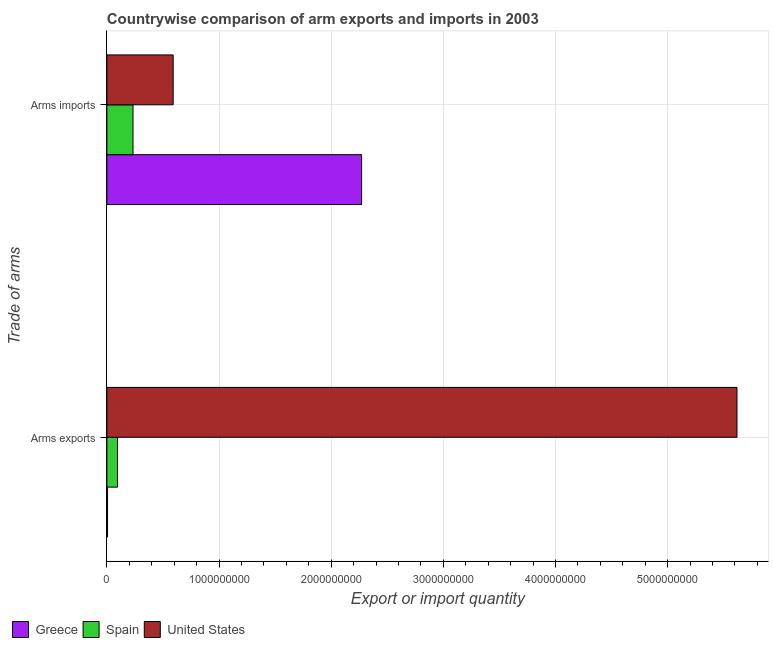Are the number of bars per tick equal to the number of legend labels?
Your answer should be compact. Yes. Are the number of bars on each tick of the Y-axis equal?
Make the answer very short. Yes. What is the label of the 1st group of bars from the top?
Keep it short and to the point. Arms imports. What is the arms exports in Greece?
Your answer should be compact. 6.00e+06. Across all countries, what is the maximum arms imports?
Keep it short and to the point. 2.27e+09. Across all countries, what is the minimum arms imports?
Offer a very short reply. 2.33e+08. In which country was the arms imports maximum?
Make the answer very short. Greece. In which country was the arms exports minimum?
Your answer should be compact. Greece. What is the total arms exports in the graph?
Your answer should be compact. 5.72e+09. What is the difference between the arms exports in Greece and that in United States?
Keep it short and to the point. -5.61e+09. What is the difference between the arms exports in Spain and the arms imports in Greece?
Ensure brevity in your answer.  -2.18e+09. What is the average arms exports per country?
Provide a succinct answer. 1.91e+09. What is the difference between the arms exports and arms imports in Spain?
Make the answer very short. -1.38e+08. What is the ratio of the arms exports in Spain to that in Greece?
Keep it short and to the point. 15.83. What does the 1st bar from the top in Arms imports represents?
Keep it short and to the point. United States. How many bars are there?
Ensure brevity in your answer.  6. How many countries are there in the graph?
Offer a very short reply. 3. Does the graph contain any zero values?
Offer a very short reply. No. How are the legend labels stacked?
Your answer should be very brief. Horizontal. What is the title of the graph?
Give a very brief answer. Countrywise comparison of arm exports and imports in 2003. Does "Seychelles" appear as one of the legend labels in the graph?
Offer a very short reply. No. What is the label or title of the X-axis?
Keep it short and to the point. Export or import quantity. What is the label or title of the Y-axis?
Your response must be concise. Trade of arms. What is the Export or import quantity in Greece in Arms exports?
Your answer should be very brief. 6.00e+06. What is the Export or import quantity of Spain in Arms exports?
Provide a succinct answer. 9.50e+07. What is the Export or import quantity of United States in Arms exports?
Provide a succinct answer. 5.62e+09. What is the Export or import quantity in Greece in Arms imports?
Your response must be concise. 2.27e+09. What is the Export or import quantity of Spain in Arms imports?
Offer a very short reply. 2.33e+08. What is the Export or import quantity of United States in Arms imports?
Give a very brief answer. 5.91e+08. Across all Trade of arms, what is the maximum Export or import quantity in Greece?
Provide a short and direct response. 2.27e+09. Across all Trade of arms, what is the maximum Export or import quantity of Spain?
Make the answer very short. 2.33e+08. Across all Trade of arms, what is the maximum Export or import quantity in United States?
Your response must be concise. 5.62e+09. Across all Trade of arms, what is the minimum Export or import quantity of Greece?
Offer a terse response. 6.00e+06. Across all Trade of arms, what is the minimum Export or import quantity of Spain?
Provide a short and direct response. 9.50e+07. Across all Trade of arms, what is the minimum Export or import quantity of United States?
Keep it short and to the point. 5.91e+08. What is the total Export or import quantity in Greece in the graph?
Make the answer very short. 2.28e+09. What is the total Export or import quantity of Spain in the graph?
Provide a succinct answer. 3.28e+08. What is the total Export or import quantity of United States in the graph?
Your response must be concise. 6.21e+09. What is the difference between the Export or import quantity in Greece in Arms exports and that in Arms imports?
Keep it short and to the point. -2.26e+09. What is the difference between the Export or import quantity of Spain in Arms exports and that in Arms imports?
Your answer should be very brief. -1.38e+08. What is the difference between the Export or import quantity in United States in Arms exports and that in Arms imports?
Your answer should be compact. 5.03e+09. What is the difference between the Export or import quantity in Greece in Arms exports and the Export or import quantity in Spain in Arms imports?
Offer a terse response. -2.27e+08. What is the difference between the Export or import quantity of Greece in Arms exports and the Export or import quantity of United States in Arms imports?
Make the answer very short. -5.85e+08. What is the difference between the Export or import quantity in Spain in Arms exports and the Export or import quantity in United States in Arms imports?
Provide a succinct answer. -4.96e+08. What is the average Export or import quantity in Greece per Trade of arms?
Your response must be concise. 1.14e+09. What is the average Export or import quantity in Spain per Trade of arms?
Your answer should be compact. 1.64e+08. What is the average Export or import quantity of United States per Trade of arms?
Give a very brief answer. 3.10e+09. What is the difference between the Export or import quantity in Greece and Export or import quantity in Spain in Arms exports?
Your answer should be compact. -8.90e+07. What is the difference between the Export or import quantity of Greece and Export or import quantity of United States in Arms exports?
Give a very brief answer. -5.61e+09. What is the difference between the Export or import quantity of Spain and Export or import quantity of United States in Arms exports?
Keep it short and to the point. -5.52e+09. What is the difference between the Export or import quantity in Greece and Export or import quantity in Spain in Arms imports?
Provide a short and direct response. 2.04e+09. What is the difference between the Export or import quantity of Greece and Export or import quantity of United States in Arms imports?
Your response must be concise. 1.68e+09. What is the difference between the Export or import quantity in Spain and Export or import quantity in United States in Arms imports?
Provide a succinct answer. -3.58e+08. What is the ratio of the Export or import quantity in Greece in Arms exports to that in Arms imports?
Your response must be concise. 0. What is the ratio of the Export or import quantity in Spain in Arms exports to that in Arms imports?
Your answer should be very brief. 0.41. What is the ratio of the Export or import quantity in United States in Arms exports to that in Arms imports?
Offer a very short reply. 9.51. What is the difference between the highest and the second highest Export or import quantity of Greece?
Provide a short and direct response. 2.26e+09. What is the difference between the highest and the second highest Export or import quantity of Spain?
Make the answer very short. 1.38e+08. What is the difference between the highest and the second highest Export or import quantity in United States?
Give a very brief answer. 5.03e+09. What is the difference between the highest and the lowest Export or import quantity of Greece?
Keep it short and to the point. 2.26e+09. What is the difference between the highest and the lowest Export or import quantity in Spain?
Keep it short and to the point. 1.38e+08. What is the difference between the highest and the lowest Export or import quantity of United States?
Provide a succinct answer. 5.03e+09. 